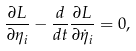Convert formula to latex. <formula><loc_0><loc_0><loc_500><loc_500>\frac { \partial { L } } { \partial \eta _ { i } } - \frac { d } { d t } \frac { \partial { L } } { \partial \dot { \eta } _ { i } } = 0 ,</formula> 